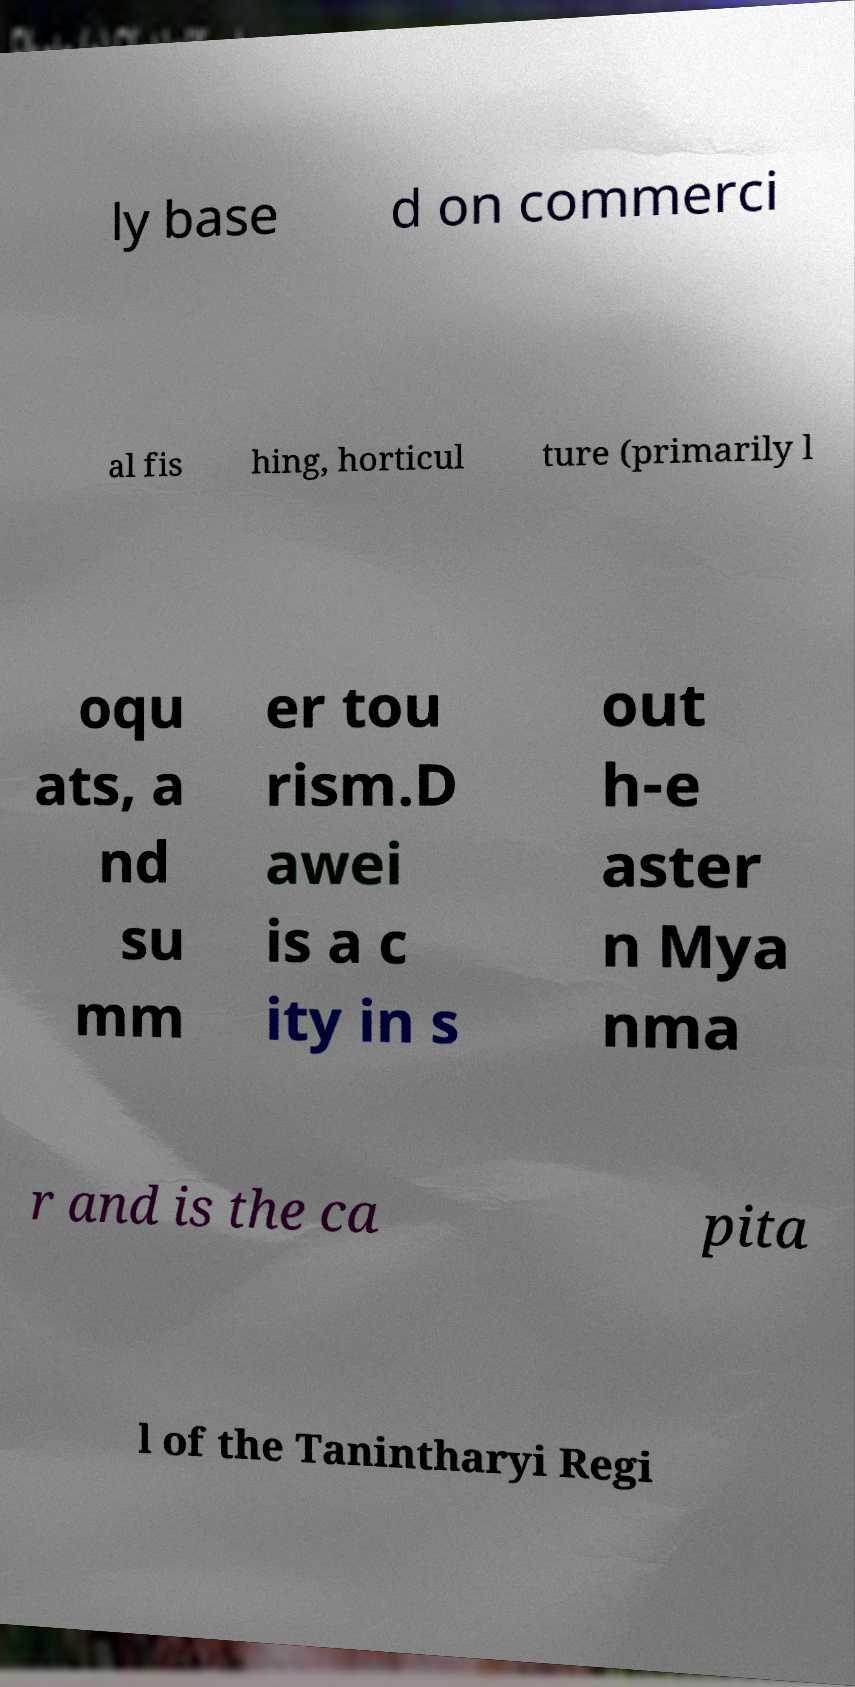Could you extract and type out the text from this image? ly base d on commerci al fis hing, horticul ture (primarily l oqu ats, a nd su mm er tou rism.D awei is a c ity in s out h-e aster n Mya nma r and is the ca pita l of the Tanintharyi Regi 